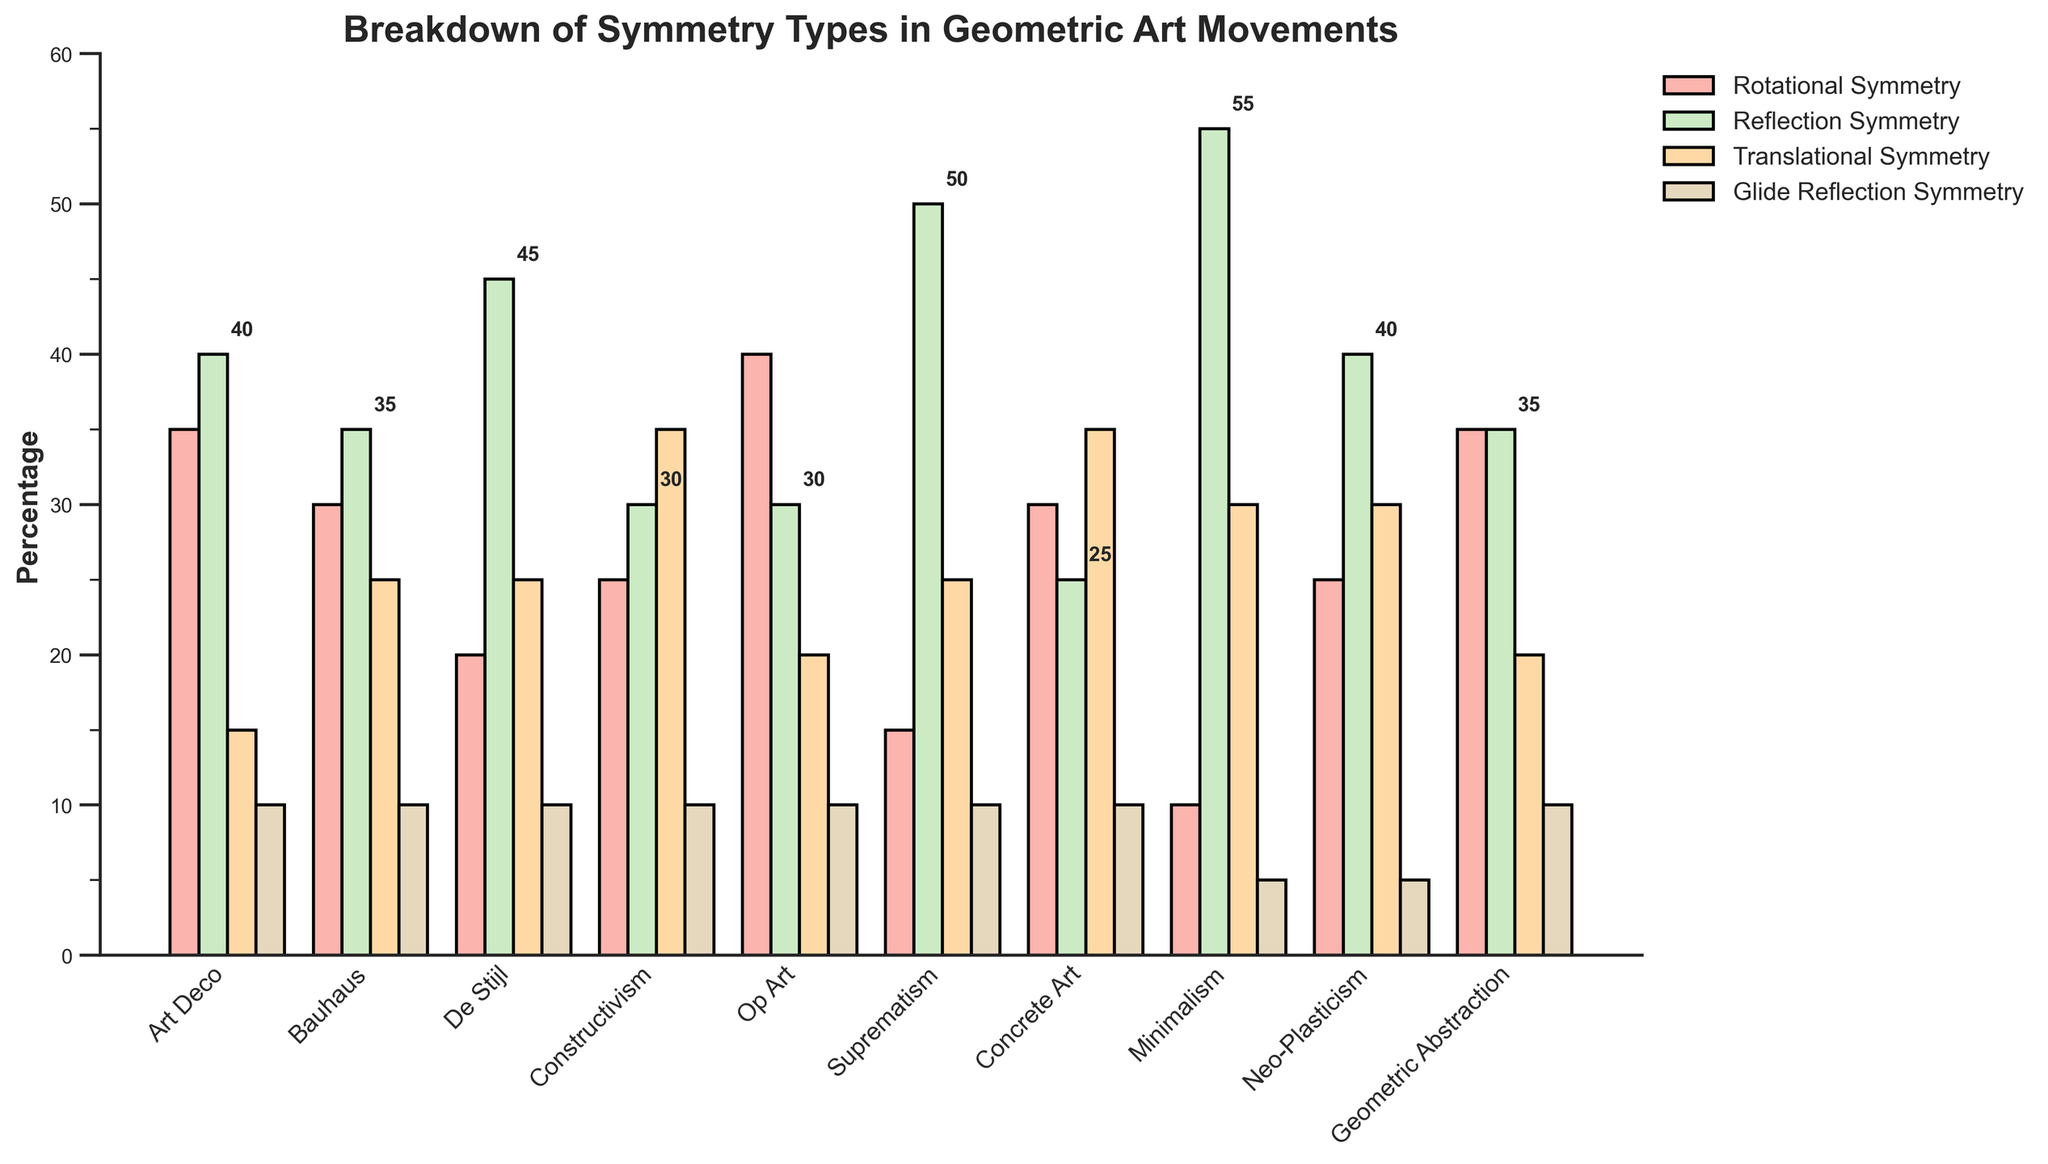what's the sum of the percentages for Rotational and Translational Symmetry in Art Deco? We look at the Art Deco row and add the percentages of Rotational Symmetry (35) and Translational Symmetry (15). Thus, 35 + 15 = 50.
Answer: 50 Which movement has the highest percentage of Reflection Symmetry? Going through the percentages of Reflection Symmetry for each movement, we see that Minimalism has the highest percentage at 55%.
Answer: Minimalism Which symmetry type has the overall lowest average percentage across movements? Calculate the average for each symmetry type: Rotational (280/10=28), Reflection (405/10=40.5), Translational (255/10=25.5), Glide Reflection (90/10=9). Glide Reflection Symmetry has the lowest average of 9.
Answer: Glide Reflection Symmetry Is there any movement where the percentage of Rotational Symmetry equals the percentage of Reflection Symmetry? Checking each movement, none of them have equal percentages for Rotational and Reflection Symmetry.
Answer: No Which movements have a higher percentage of Translations Symmetry compared to Glide Reflection Symmetry? All movements have higher percentages for Translational Symmetry (ranging from 15 to 35) compared to Glide Reflection Symmetry (uniformly 10, except for Minimalism and Neo-Plasticism at 5).
Answer: All movements What's the range of the percentages for Reflection Symmetry across all movements? We determine the minimum (25 in Concrete Art) and maximum (55 in Minimalism) percentages for Reflection Symmetry and compute the range as 55 - 25 = 30.
Answer: 30 Between Op Art and Constructivism, which one has a greater percentage of Rotational Symmetry? Op Art has 40% for Rotational Symmetry, while Constructivism has 25%. Hence, Op Art has a greater percentage.
Answer: Op Art For which movements does Reflection Symmetry exceed 40%? Looking at Reflection Symmetry percentages, De Stijl (45), Suprematism (50), and Minimalism (55) exceed 40%.
Answer: De Stijl, Suprematism, Minimalism What's the percentage difference between Rotational and Translational Symmetry for Concrete Art? For Concrete Art, Rotational Symmetry is 30%, and Translational Symmetry is 35%. The difference is calculated as 35 - 30 = 5.
Answer: 5 